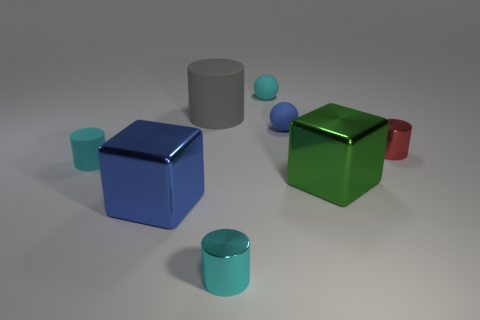There is a tiny sphere that is the same color as the tiny matte cylinder; what is it made of?
Your answer should be very brief. Rubber. How many other small cylinders are the same color as the small rubber cylinder?
Your answer should be very brief. 1. Is there anything else that has the same size as the green metallic cube?
Ensure brevity in your answer.  Yes. Do the gray matte thing and the red metallic cylinder have the same size?
Your answer should be compact. No. What number of objects are either tiny cyan things on the right side of the big blue block or tiny matte things that are on the left side of the large gray matte cylinder?
Offer a terse response. 3. Are there more tiny rubber balls in front of the gray matte cylinder than brown rubber cylinders?
Provide a succinct answer. Yes. What number of other objects are there of the same shape as the big gray object?
Your response must be concise. 3. What is the material of the object that is both behind the tiny blue rubber ball and left of the small cyan metallic cylinder?
Your response must be concise. Rubber. What number of objects are either blue cylinders or small red shiny things?
Make the answer very short. 1. Are there more brown metallic objects than big cubes?
Offer a very short reply. No. 